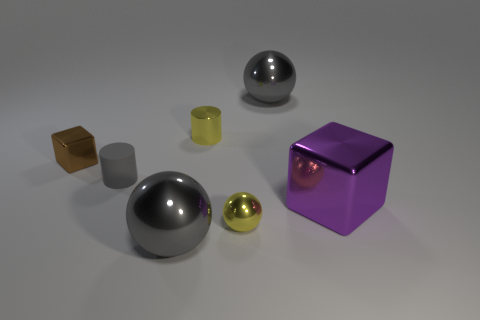Do the tiny yellow sphere right of the small brown metallic cube and the gray thing in front of the small metal ball have the same material?
Your answer should be compact. Yes. Are there any other things that have the same shape as the purple metallic thing?
Keep it short and to the point. Yes. What color is the tiny shiny ball?
Make the answer very short. Yellow. How many small metal things have the same shape as the gray rubber thing?
Your response must be concise. 1. There is a block that is the same size as the matte cylinder; what is its color?
Make the answer very short. Brown. Are there any big blue cylinders?
Provide a short and direct response. No. There is a big purple metal thing that is in front of the rubber thing; what shape is it?
Your answer should be very brief. Cube. What number of tiny objects are both to the right of the gray cylinder and to the left of the rubber thing?
Keep it short and to the point. 0. Is there a big gray ball made of the same material as the large purple cube?
Provide a succinct answer. Yes. What size is the metal cylinder that is the same color as the tiny ball?
Provide a succinct answer. Small. 